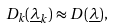<formula> <loc_0><loc_0><loc_500><loc_500>D _ { k } ( \underline { \lambda } _ { k } ) \approx D ( \underline { \lambda } ) ,</formula> 